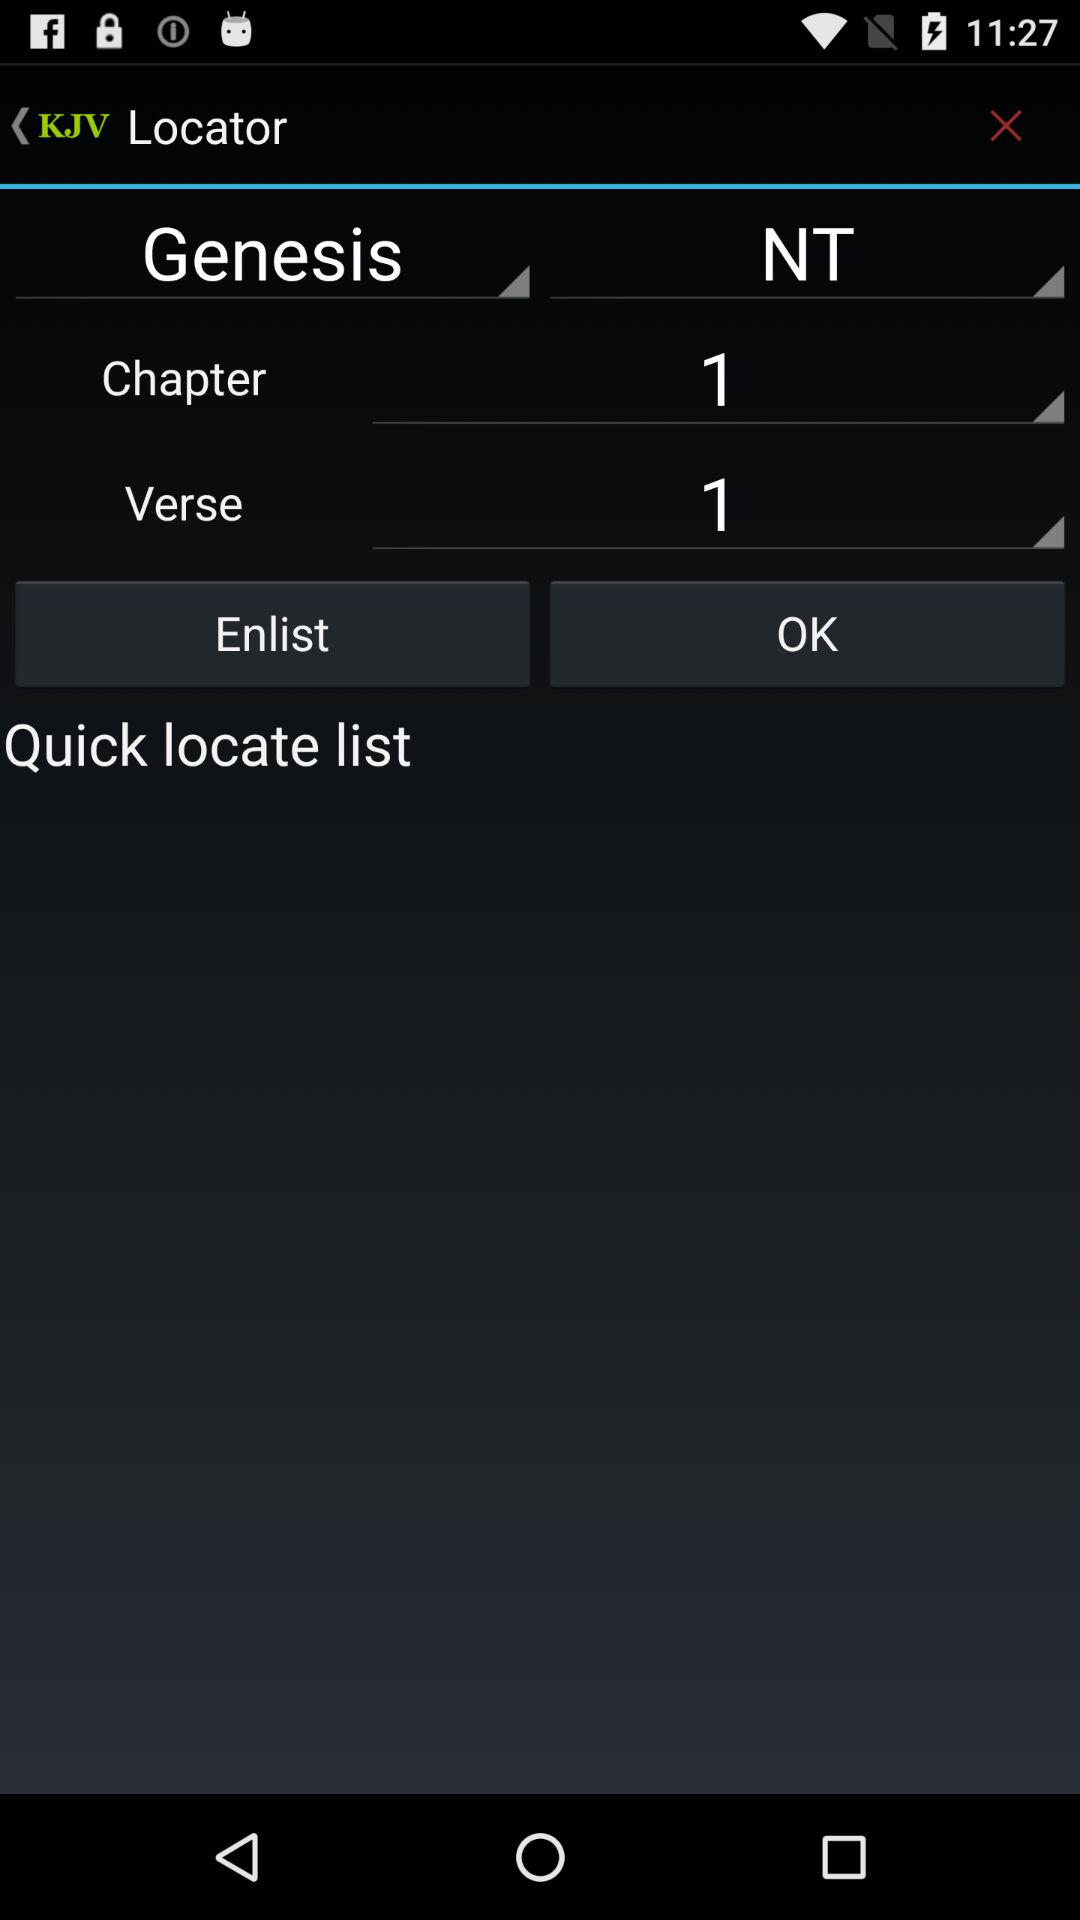What verse of the chapter is selected? The selected verse of the chapter is 1. 